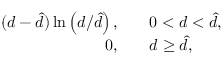<formula> <loc_0><loc_0><loc_500><loc_500>\begin{array} { r l } { ( d - \hat { d } ) \ln \left ( d / \hat { d } \right ) , \quad } & 0 < d < \hat { d } , } \\ { 0 , \quad } & d \geq \hat { d } , } \end{array}</formula> 